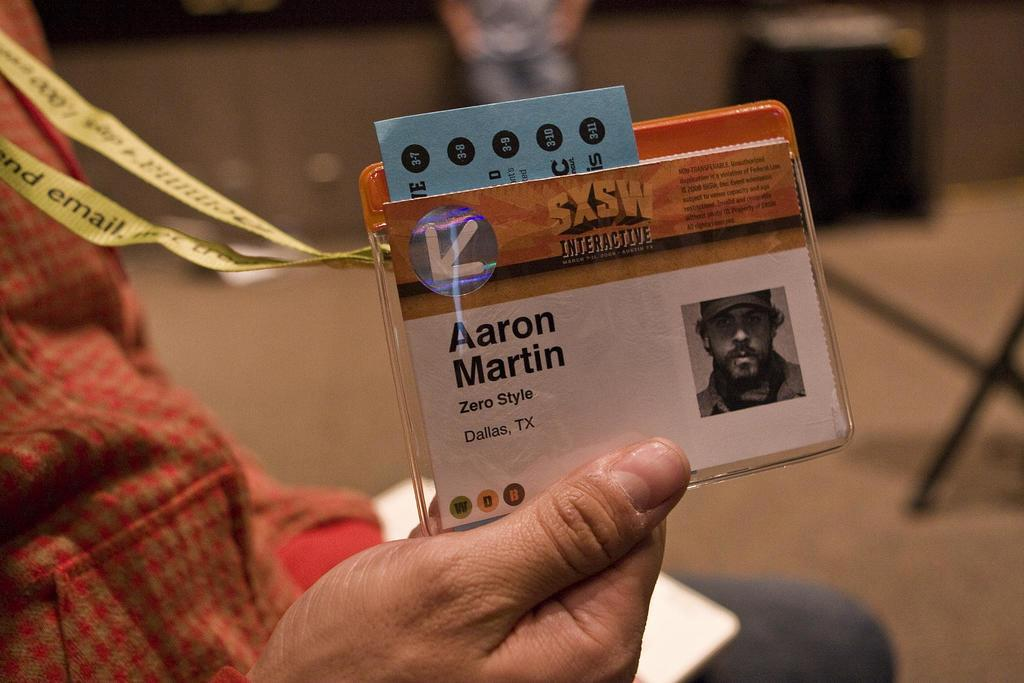What is the person's hand holding in the image? There is a person's hand holding an ID card in the image. Can you describe the background of the image? The background of the image is blurry. What type of vest is the person wearing in the image? There is no vest visible in the image; only a person's hand holding an ID card is present. What part of the person's body can be seen in the image? Only the person's hand is visible in the image. 